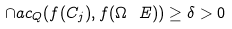<formula> <loc_0><loc_0><loc_500><loc_500>\cap a c _ { Q } ( f ( C _ { j } ) , f ( \Omega \ E ) ) \geq \delta > 0</formula> 